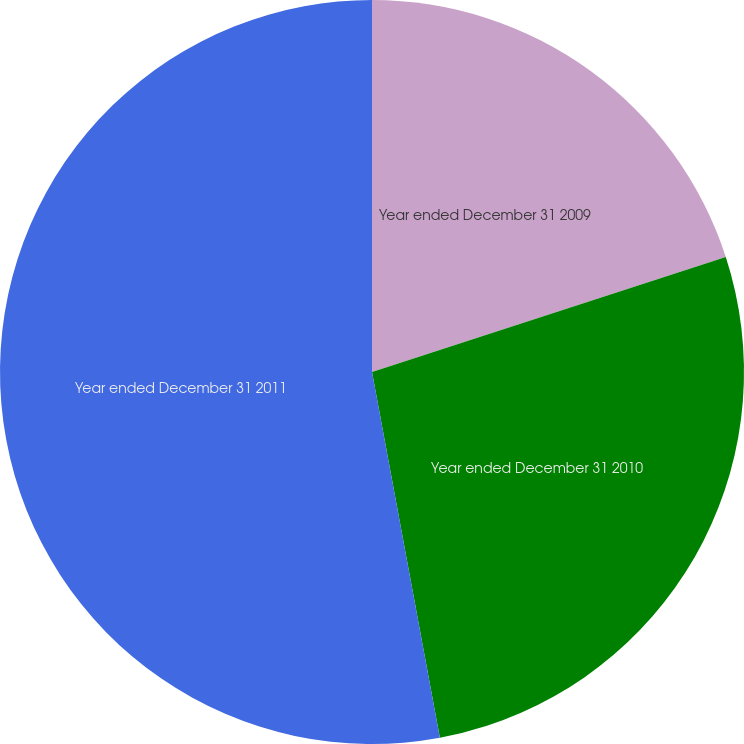Convert chart to OTSL. <chart><loc_0><loc_0><loc_500><loc_500><pie_chart><fcel>Year ended December 31 2009<fcel>Year ended December 31 2010<fcel>Year ended December 31 2011<nl><fcel>20.0%<fcel>27.08%<fcel>52.92%<nl></chart> 